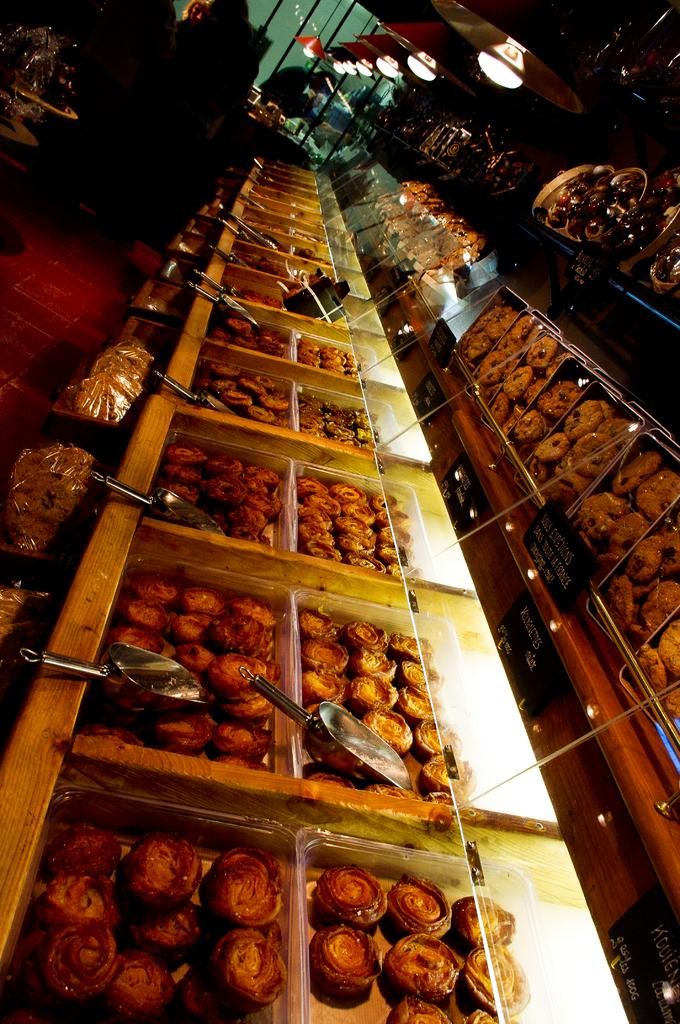What type of items are arranged in boxes in the image? The image shows food items arranged in boxes. Can you describe the lighting in the image? There are lights at the top of the image. How does the harmony between the wilderness and the food items in the image contribute to the overall aesthetic? There is no wilderness present in the image, as it only shows food items arranged in boxes and lights at the top. 